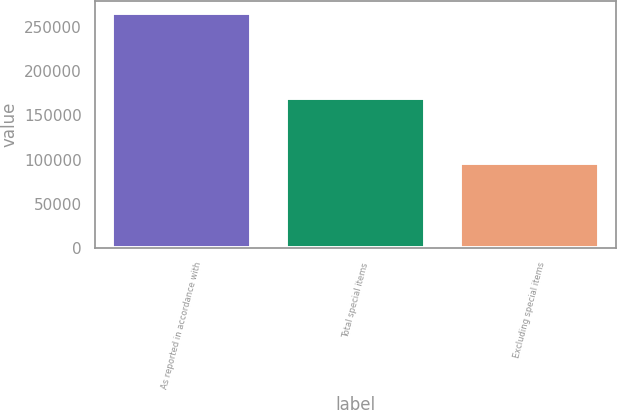Convert chart. <chart><loc_0><loc_0><loc_500><loc_500><bar_chart><fcel>As reported in accordance with<fcel>Total special items<fcel>Excluding special items<nl><fcel>265895<fcel>170031<fcel>95864<nl></chart> 